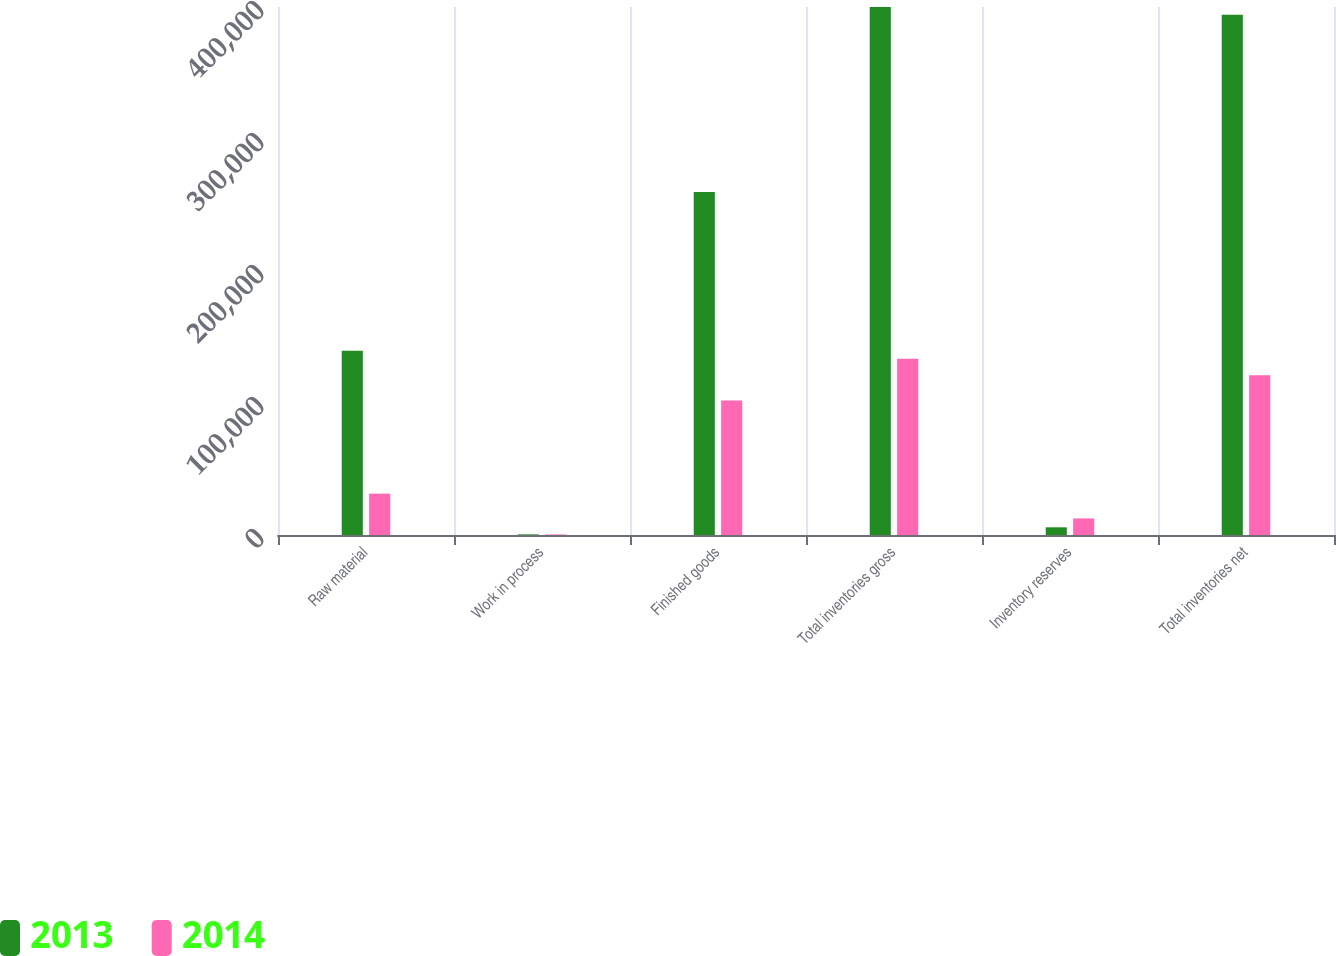Convert chart to OTSL. <chart><loc_0><loc_0><loc_500><loc_500><stacked_bar_chart><ecel><fcel>Raw material<fcel>Work in process<fcel>Finished goods<fcel>Total inventories gross<fcel>Inventory reserves<fcel>Total inventories net<nl><fcel>2013<fcel>139647<fcel>476<fcel>259872<fcel>399995<fcel>5819<fcel>394176<nl><fcel>2014<fcel>31335<fcel>415<fcel>101834<fcel>133584<fcel>12561<fcel>121023<nl></chart> 